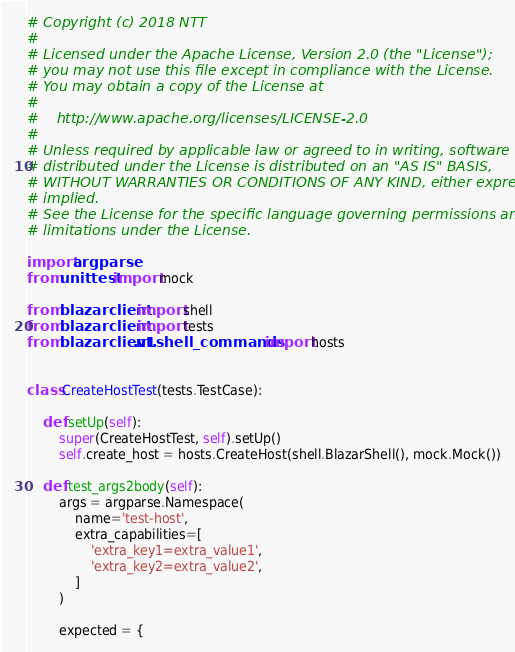<code> <loc_0><loc_0><loc_500><loc_500><_Python_># Copyright (c) 2018 NTT
#
# Licensed under the Apache License, Version 2.0 (the "License");
# you may not use this file except in compliance with the License.
# You may obtain a copy of the License at
#
#    http://www.apache.org/licenses/LICENSE-2.0
#
# Unless required by applicable law or agreed to in writing, software
# distributed under the License is distributed on an "AS IS" BASIS,
# WITHOUT WARRANTIES OR CONDITIONS OF ANY KIND, either express or
# implied.
# See the License for the specific language governing permissions and
# limitations under the License.

import argparse
from unittest import mock

from blazarclient import shell
from blazarclient import tests
from blazarclient.v1.shell_commands import hosts


class CreateHostTest(tests.TestCase):

    def setUp(self):
        super(CreateHostTest, self).setUp()
        self.create_host = hosts.CreateHost(shell.BlazarShell(), mock.Mock())

    def test_args2body(self):
        args = argparse.Namespace(
            name='test-host',
            extra_capabilities=[
                'extra_key1=extra_value1',
                'extra_key2=extra_value2',
            ]
        )

        expected = {</code> 